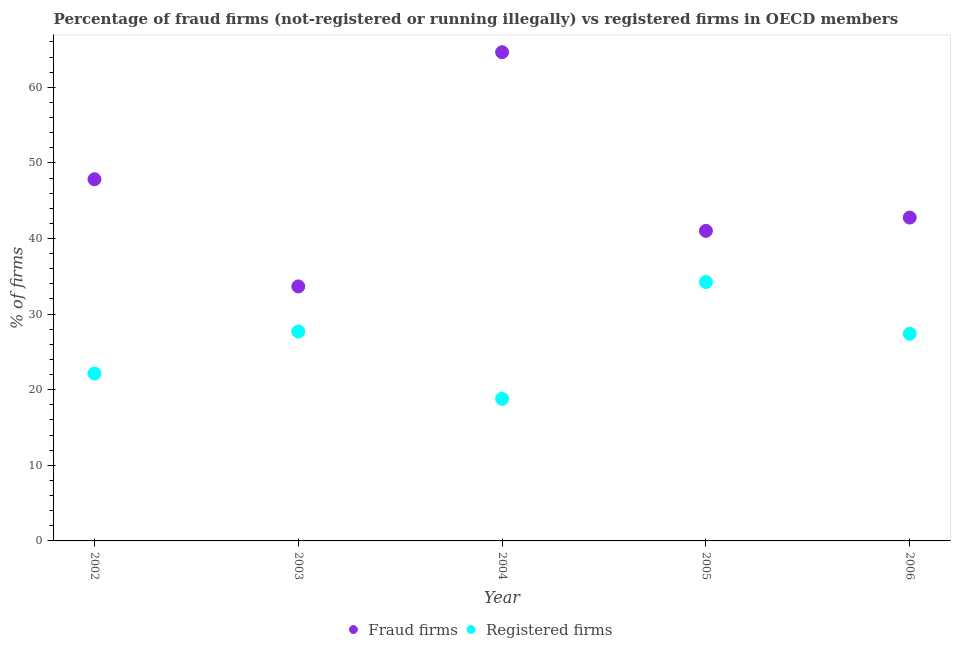What is the percentage of fraud firms in 2006?
Your response must be concise. 42.77. Across all years, what is the maximum percentage of registered firms?
Give a very brief answer. 34.24. Across all years, what is the minimum percentage of fraud firms?
Ensure brevity in your answer.  33.66. In which year was the percentage of registered firms maximum?
Ensure brevity in your answer.  2005. In which year was the percentage of registered firms minimum?
Provide a short and direct response. 2004. What is the total percentage of registered firms in the graph?
Give a very brief answer. 130.28. What is the difference between the percentage of registered firms in 2002 and that in 2006?
Your answer should be very brief. -5.26. What is the difference between the percentage of fraud firms in 2003 and the percentage of registered firms in 2002?
Offer a terse response. 11.52. What is the average percentage of fraud firms per year?
Keep it short and to the point. 45.98. In the year 2005, what is the difference between the percentage of fraud firms and percentage of registered firms?
Offer a very short reply. 6.77. In how many years, is the percentage of registered firms greater than 12 %?
Provide a succinct answer. 5. What is the ratio of the percentage of fraud firms in 2004 to that in 2006?
Offer a terse response. 1.51. What is the difference between the highest and the second highest percentage of registered firms?
Give a very brief answer. 6.54. What is the difference between the highest and the lowest percentage of registered firms?
Ensure brevity in your answer.  15.44. Is the sum of the percentage of fraud firms in 2004 and 2006 greater than the maximum percentage of registered firms across all years?
Your answer should be compact. Yes. Does the percentage of registered firms monotonically increase over the years?
Provide a succinct answer. No. Is the percentage of fraud firms strictly greater than the percentage of registered firms over the years?
Keep it short and to the point. Yes. How many legend labels are there?
Make the answer very short. 2. What is the title of the graph?
Offer a very short reply. Percentage of fraud firms (not-registered or running illegally) vs registered firms in OECD members. What is the label or title of the X-axis?
Provide a short and direct response. Year. What is the label or title of the Y-axis?
Make the answer very short. % of firms. What is the % of firms in Fraud firms in 2002?
Make the answer very short. 47.84. What is the % of firms of Registered firms in 2002?
Offer a terse response. 22.14. What is the % of firms in Fraud firms in 2003?
Ensure brevity in your answer.  33.66. What is the % of firms of Registered firms in 2003?
Offer a terse response. 27.7. What is the % of firms of Fraud firms in 2004?
Your answer should be compact. 64.64. What is the % of firms in Fraud firms in 2005?
Your answer should be compact. 41.01. What is the % of firms of Registered firms in 2005?
Provide a succinct answer. 34.24. What is the % of firms of Fraud firms in 2006?
Make the answer very short. 42.77. What is the % of firms in Registered firms in 2006?
Your answer should be very brief. 27.4. Across all years, what is the maximum % of firms in Fraud firms?
Your response must be concise. 64.64. Across all years, what is the maximum % of firms of Registered firms?
Provide a short and direct response. 34.24. Across all years, what is the minimum % of firms in Fraud firms?
Provide a short and direct response. 33.66. Across all years, what is the minimum % of firms in Registered firms?
Offer a terse response. 18.8. What is the total % of firms of Fraud firms in the graph?
Give a very brief answer. 229.92. What is the total % of firms of Registered firms in the graph?
Make the answer very short. 130.28. What is the difference between the % of firms in Fraud firms in 2002 and that in 2003?
Provide a succinct answer. 14.18. What is the difference between the % of firms of Registered firms in 2002 and that in 2003?
Keep it short and to the point. -5.56. What is the difference between the % of firms in Fraud firms in 2002 and that in 2004?
Keep it short and to the point. -16.8. What is the difference between the % of firms in Registered firms in 2002 and that in 2004?
Offer a terse response. 3.34. What is the difference between the % of firms in Fraud firms in 2002 and that in 2005?
Your answer should be compact. 6.83. What is the difference between the % of firms of Registered firms in 2002 and that in 2005?
Make the answer very short. -12.1. What is the difference between the % of firms of Fraud firms in 2002 and that in 2006?
Ensure brevity in your answer.  5.07. What is the difference between the % of firms in Registered firms in 2002 and that in 2006?
Your response must be concise. -5.26. What is the difference between the % of firms in Fraud firms in 2003 and that in 2004?
Give a very brief answer. -30.98. What is the difference between the % of firms of Fraud firms in 2003 and that in 2005?
Provide a succinct answer. -7.35. What is the difference between the % of firms of Registered firms in 2003 and that in 2005?
Keep it short and to the point. -6.54. What is the difference between the % of firms of Fraud firms in 2003 and that in 2006?
Your answer should be compact. -9.11. What is the difference between the % of firms in Registered firms in 2003 and that in 2006?
Provide a short and direct response. 0.3. What is the difference between the % of firms in Fraud firms in 2004 and that in 2005?
Keep it short and to the point. 23.63. What is the difference between the % of firms in Registered firms in 2004 and that in 2005?
Your answer should be compact. -15.44. What is the difference between the % of firms in Fraud firms in 2004 and that in 2006?
Your answer should be very brief. 21.87. What is the difference between the % of firms of Registered firms in 2004 and that in 2006?
Offer a very short reply. -8.6. What is the difference between the % of firms of Fraud firms in 2005 and that in 2006?
Ensure brevity in your answer.  -1.76. What is the difference between the % of firms of Registered firms in 2005 and that in 2006?
Your answer should be very brief. 6.84. What is the difference between the % of firms of Fraud firms in 2002 and the % of firms of Registered firms in 2003?
Keep it short and to the point. 20.14. What is the difference between the % of firms in Fraud firms in 2002 and the % of firms in Registered firms in 2004?
Give a very brief answer. 29.04. What is the difference between the % of firms in Fraud firms in 2002 and the % of firms in Registered firms in 2005?
Provide a short and direct response. 13.6. What is the difference between the % of firms of Fraud firms in 2002 and the % of firms of Registered firms in 2006?
Provide a succinct answer. 20.44. What is the difference between the % of firms of Fraud firms in 2003 and the % of firms of Registered firms in 2004?
Keep it short and to the point. 14.86. What is the difference between the % of firms in Fraud firms in 2003 and the % of firms in Registered firms in 2005?
Provide a short and direct response. -0.58. What is the difference between the % of firms in Fraud firms in 2003 and the % of firms in Registered firms in 2006?
Offer a very short reply. 6.26. What is the difference between the % of firms of Fraud firms in 2004 and the % of firms of Registered firms in 2005?
Ensure brevity in your answer.  30.4. What is the difference between the % of firms of Fraud firms in 2004 and the % of firms of Registered firms in 2006?
Keep it short and to the point. 37.24. What is the difference between the % of firms in Fraud firms in 2005 and the % of firms in Registered firms in 2006?
Your answer should be compact. 13.61. What is the average % of firms in Fraud firms per year?
Provide a succinct answer. 45.98. What is the average % of firms of Registered firms per year?
Keep it short and to the point. 26.06. In the year 2002, what is the difference between the % of firms in Fraud firms and % of firms in Registered firms?
Your response must be concise. 25.69. In the year 2003, what is the difference between the % of firms of Fraud firms and % of firms of Registered firms?
Keep it short and to the point. 5.96. In the year 2004, what is the difference between the % of firms of Fraud firms and % of firms of Registered firms?
Offer a very short reply. 45.84. In the year 2005, what is the difference between the % of firms in Fraud firms and % of firms in Registered firms?
Offer a very short reply. 6.77. In the year 2006, what is the difference between the % of firms of Fraud firms and % of firms of Registered firms?
Offer a very short reply. 15.37. What is the ratio of the % of firms of Fraud firms in 2002 to that in 2003?
Your answer should be compact. 1.42. What is the ratio of the % of firms in Registered firms in 2002 to that in 2003?
Provide a short and direct response. 0.8. What is the ratio of the % of firms in Fraud firms in 2002 to that in 2004?
Provide a short and direct response. 0.74. What is the ratio of the % of firms of Registered firms in 2002 to that in 2004?
Provide a succinct answer. 1.18. What is the ratio of the % of firms of Fraud firms in 2002 to that in 2005?
Your response must be concise. 1.17. What is the ratio of the % of firms of Registered firms in 2002 to that in 2005?
Offer a terse response. 0.65. What is the ratio of the % of firms of Fraud firms in 2002 to that in 2006?
Give a very brief answer. 1.12. What is the ratio of the % of firms of Registered firms in 2002 to that in 2006?
Your answer should be compact. 0.81. What is the ratio of the % of firms in Fraud firms in 2003 to that in 2004?
Offer a very short reply. 0.52. What is the ratio of the % of firms in Registered firms in 2003 to that in 2004?
Offer a terse response. 1.47. What is the ratio of the % of firms of Fraud firms in 2003 to that in 2005?
Keep it short and to the point. 0.82. What is the ratio of the % of firms in Registered firms in 2003 to that in 2005?
Ensure brevity in your answer.  0.81. What is the ratio of the % of firms of Fraud firms in 2003 to that in 2006?
Make the answer very short. 0.79. What is the ratio of the % of firms of Registered firms in 2003 to that in 2006?
Your response must be concise. 1.01. What is the ratio of the % of firms of Fraud firms in 2004 to that in 2005?
Make the answer very short. 1.58. What is the ratio of the % of firms in Registered firms in 2004 to that in 2005?
Offer a terse response. 0.55. What is the ratio of the % of firms in Fraud firms in 2004 to that in 2006?
Your response must be concise. 1.51. What is the ratio of the % of firms in Registered firms in 2004 to that in 2006?
Keep it short and to the point. 0.69. What is the ratio of the % of firms in Fraud firms in 2005 to that in 2006?
Your answer should be compact. 0.96. What is the ratio of the % of firms of Registered firms in 2005 to that in 2006?
Provide a short and direct response. 1.25. What is the difference between the highest and the second highest % of firms of Fraud firms?
Ensure brevity in your answer.  16.8. What is the difference between the highest and the second highest % of firms in Registered firms?
Your response must be concise. 6.54. What is the difference between the highest and the lowest % of firms in Fraud firms?
Ensure brevity in your answer.  30.98. What is the difference between the highest and the lowest % of firms in Registered firms?
Provide a succinct answer. 15.44. 